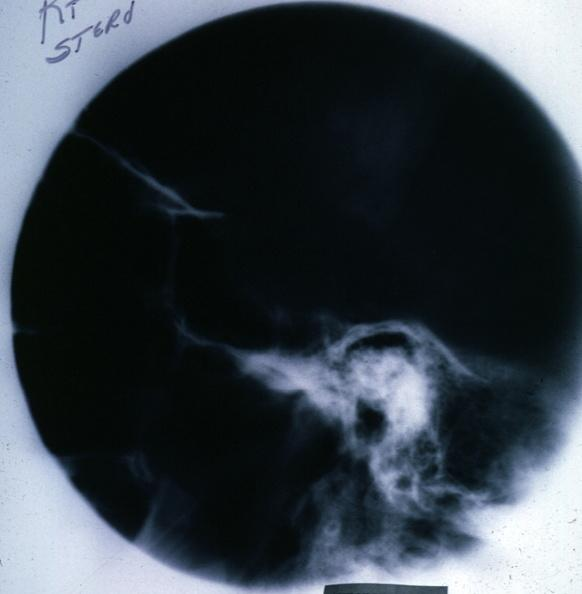s tuberculosis present?
Answer the question using a single word or phrase. No 